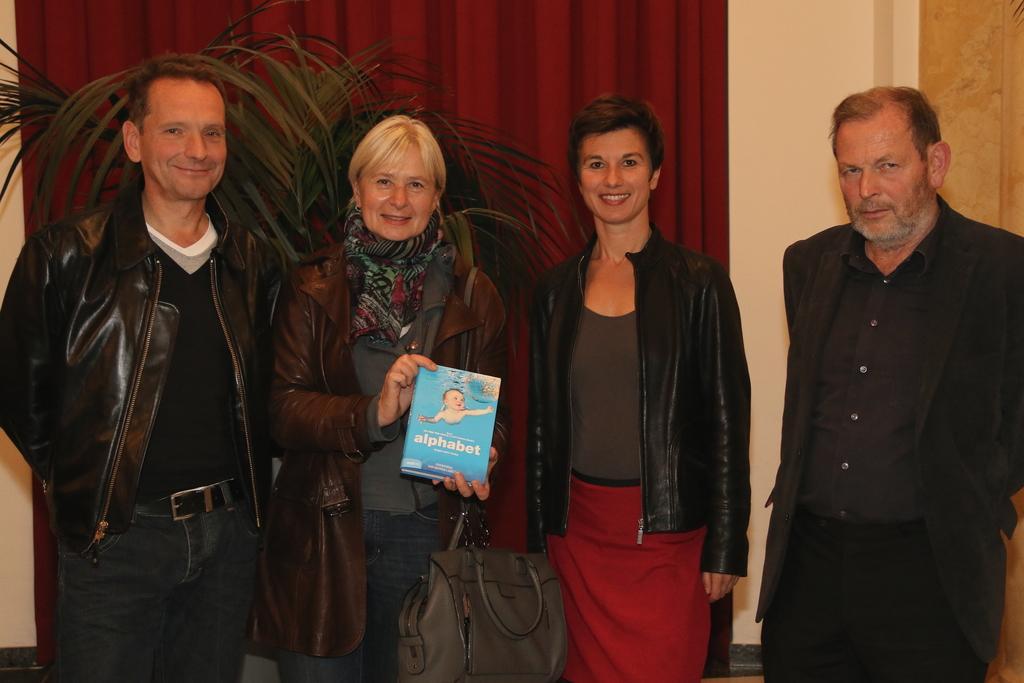Can you describe this image briefly? In the picture I can see four persons standing on the floor and there is a smile on their faces. I can see a woman holding a book in her hand and she is carrying a handbag. In the background, I can see a red color curtain and a plant. 